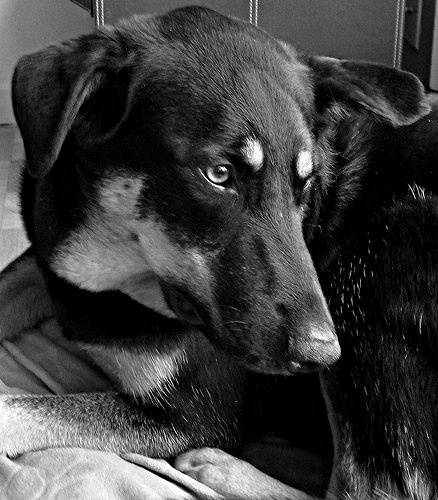Describe the objects in this image and their specific colors. I can see a dog in black, darkgray, gray, and gainsboro tones in this image. 